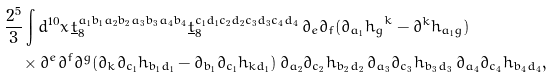Convert formula to latex. <formula><loc_0><loc_0><loc_500><loc_500>& \frac { 2 ^ { 5 } } { 3 } \int d ^ { 1 0 } x \, \underline { t } _ { 8 } ^ { a _ { 1 } b _ { 1 } a _ { 2 } b _ { 2 } a _ { 3 } b _ { 3 } a _ { 4 } b _ { 4 } } \underline { t } _ { 8 } ^ { c _ { 1 } d _ { 1 } c _ { 2 } d _ { 2 } c _ { 3 } d _ { 3 } c _ { 4 } d _ { 4 } } \, \partial _ { e } \partial _ { f } ( \partial _ { a _ { 1 } } { h _ { g } } ^ { k } - \partial ^ { k } h _ { a _ { 1 } g } ) \\ & \quad \times \partial ^ { e } \partial ^ { f } \partial ^ { g } ( \partial _ { k } \partial _ { c _ { 1 } } h _ { b _ { 1 } d _ { 1 } } - \partial _ { b _ { 1 } } \partial _ { c _ { 1 } } h _ { k d _ { 1 } } ) \, \partial _ { a _ { 2 } } \partial _ { c _ { 2 } } h _ { b _ { 2 } d _ { 2 } } \, \partial _ { a _ { 3 } } \partial _ { c _ { 3 } } h _ { b _ { 3 } d _ { 3 } } \, \partial _ { a _ { 4 } } \partial _ { c _ { 4 } } h _ { b _ { 4 } d _ { 4 } } ,</formula> 